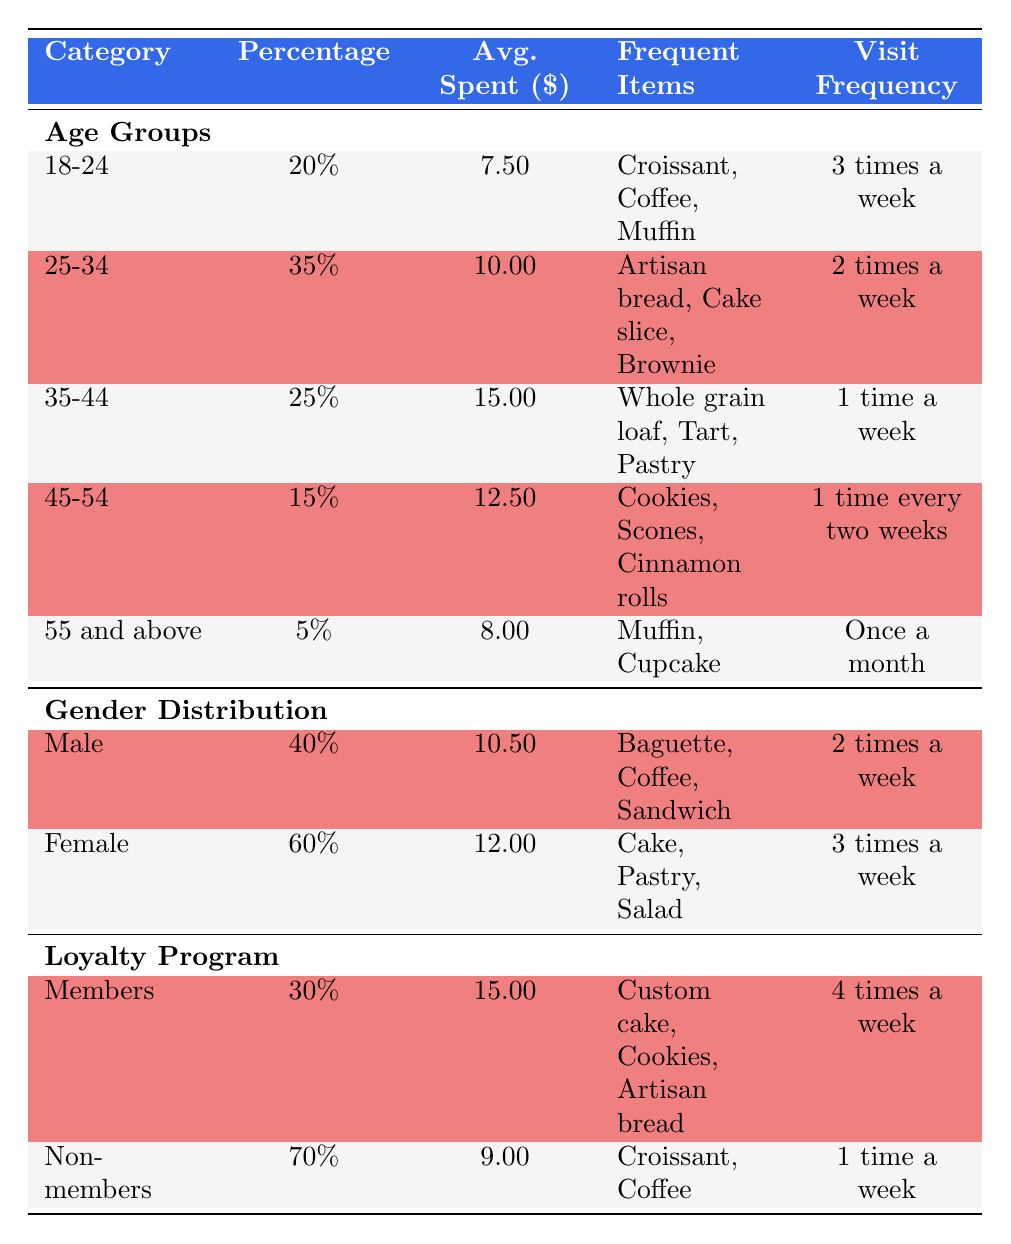What percentage of customers are aged 18-24? According to the table under the Age Groups section, the percentage listed for the age group 18-24 is 20%.
Answer: 20% What is the average amount spent by female customers? The table shows that female customers have an average expenditure of 12.00, which is noted under the Gender Distribution section.
Answer: 12.00 Which age group visits the bakery most frequently? The age group 18-24 visits the bakery 3 times a week, which is more frequent compared to other age groups.
Answer: 18-24 What is the total percentage of loyalty program participants? By adding both members and non-members, 30% (members) + 70% (non-members) equals 100%, reflecting the total customer breakdown relevant to the loyalty program.
Answer: 100% Is the average spent by loyalty program members greater than that of non-members? According to the table, members spend an average of 15.00, while non-members spend 9.00. Since 15.00 is greater than 9.00, the statement is true.
Answer: Yes Which group spends the least on average? The least average spent is found in the age group 55 and above, with an average of 8.00, which can be seen in the Age Groups section.
Answer: 8.00 How much more do members spend on average compared to the 45-54 age group? The average spent by members is 15.00, while the average for the 45-54 age group is 12.50. The difference is 15.00 - 12.50 = 2.50.
Answer: 2.50 What frequent item do the majority of the 25-34 age group purchase? The frequent items listed for the 25-34 age group includes artisan bread, cake slice, and brownie, indicating that these items are popular among this demographic. The first item is artisan bread.
Answer: Artisan bread What percentage of male customers visit the bakery two times a week? The table indicates that male customers visit the bakery with a frequency of 2 times a week, and the percentage is shown as 40%.
Answer: 40% 